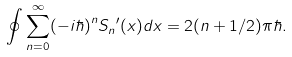Convert formula to latex. <formula><loc_0><loc_0><loc_500><loc_500>\oint \sum _ { n = 0 } ^ { \infty } ( - i \hbar { ) } ^ { n } { S _ { n } } ^ { \prime } ( x ) d x = 2 ( n + 1 / 2 ) \pi \hbar { . }</formula> 